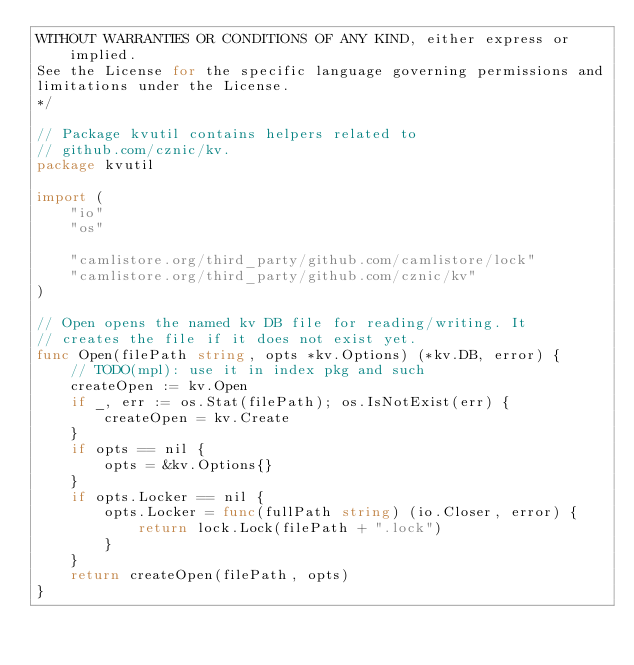Convert code to text. <code><loc_0><loc_0><loc_500><loc_500><_Go_>WITHOUT WARRANTIES OR CONDITIONS OF ANY KIND, either express or implied.
See the License for the specific language governing permissions and
limitations under the License.
*/

// Package kvutil contains helpers related to
// github.com/cznic/kv.
package kvutil

import (
	"io"
	"os"

	"camlistore.org/third_party/github.com/camlistore/lock"
	"camlistore.org/third_party/github.com/cznic/kv"
)

// Open opens the named kv DB file for reading/writing. It
// creates the file if it does not exist yet.
func Open(filePath string, opts *kv.Options) (*kv.DB, error) {
	// TODO(mpl): use it in index pkg and such
	createOpen := kv.Open
	if _, err := os.Stat(filePath); os.IsNotExist(err) {
		createOpen = kv.Create
	}
	if opts == nil {
		opts = &kv.Options{}
	}
	if opts.Locker == nil {
		opts.Locker = func(fullPath string) (io.Closer, error) {
			return lock.Lock(filePath + ".lock")
		}
	}
	return createOpen(filePath, opts)
}
</code> 